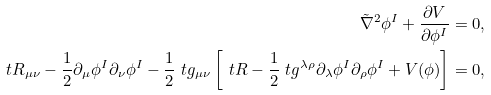Convert formula to latex. <formula><loc_0><loc_0><loc_500><loc_500>\tilde { \nabla } ^ { 2 } \phi ^ { I } + \frac { \partial V } { \partial \phi ^ { I } } = 0 , \\ \ t R _ { \mu \nu } - \frac { 1 } { 2 } \partial _ { \mu } \phi ^ { I } \partial _ { \nu } \phi ^ { I } - \frac { 1 } { 2 } \ t g _ { \mu \nu } \left [ \ t R - \frac { 1 } { 2 } \ t g ^ { \lambda \rho } \partial _ { \lambda } \phi ^ { I } \partial _ { \rho } \phi ^ { I } + V ( \phi ) \right ] = 0 ,</formula> 